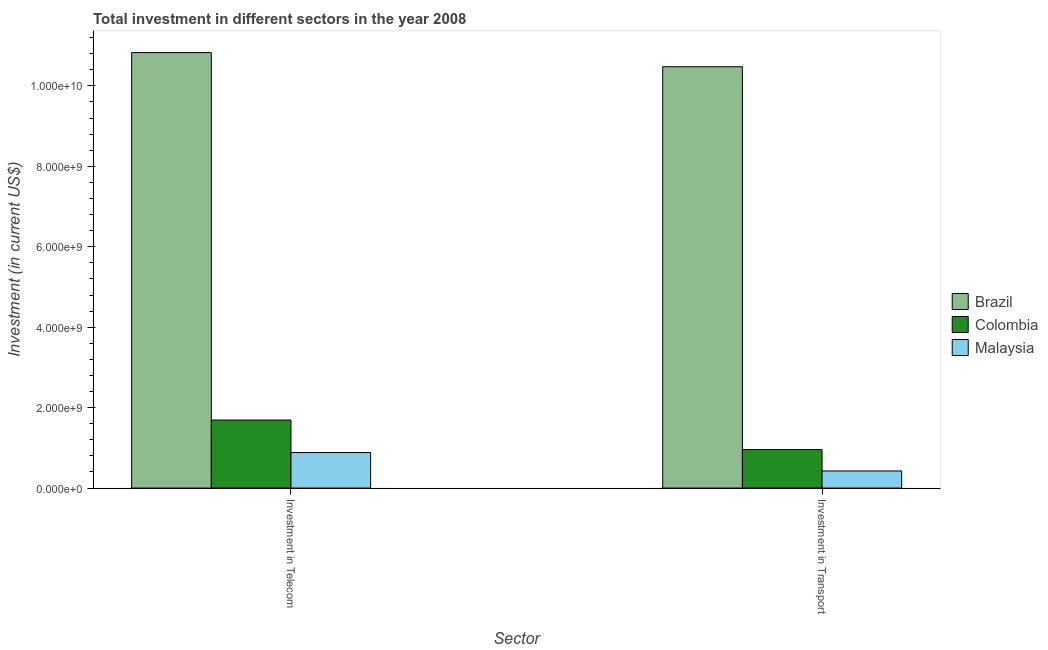How many groups of bars are there?
Offer a terse response. 2. What is the label of the 2nd group of bars from the left?
Your response must be concise. Investment in Transport. What is the investment in telecom in Malaysia?
Your answer should be very brief. 8.82e+08. Across all countries, what is the maximum investment in telecom?
Offer a terse response. 1.08e+1. Across all countries, what is the minimum investment in telecom?
Your response must be concise. 8.82e+08. In which country was the investment in transport maximum?
Your answer should be very brief. Brazil. In which country was the investment in telecom minimum?
Give a very brief answer. Malaysia. What is the total investment in telecom in the graph?
Ensure brevity in your answer.  1.34e+1. What is the difference between the investment in telecom in Colombia and that in Brazil?
Your answer should be very brief. -9.14e+09. What is the difference between the investment in telecom in Colombia and the investment in transport in Brazil?
Give a very brief answer. -8.79e+09. What is the average investment in telecom per country?
Your answer should be compact. 4.47e+09. What is the difference between the investment in telecom and investment in transport in Colombia?
Your response must be concise. 7.35e+08. In how many countries, is the investment in telecom greater than 10800000000 US$?
Provide a short and direct response. 1. What is the ratio of the investment in telecom in Colombia to that in Brazil?
Provide a succinct answer. 0.16. Is the investment in telecom in Brazil less than that in Malaysia?
Your response must be concise. No. What does the 2nd bar from the left in Investment in Telecom represents?
Ensure brevity in your answer.  Colombia. How many countries are there in the graph?
Ensure brevity in your answer.  3. Does the graph contain any zero values?
Ensure brevity in your answer.  No. Where does the legend appear in the graph?
Give a very brief answer. Center right. How many legend labels are there?
Your answer should be compact. 3. How are the legend labels stacked?
Offer a terse response. Vertical. What is the title of the graph?
Keep it short and to the point. Total investment in different sectors in the year 2008. What is the label or title of the X-axis?
Offer a very short reply. Sector. What is the label or title of the Y-axis?
Keep it short and to the point. Investment (in current US$). What is the Investment (in current US$) in Brazil in Investment in Telecom?
Your answer should be compact. 1.08e+1. What is the Investment (in current US$) of Colombia in Investment in Telecom?
Offer a terse response. 1.69e+09. What is the Investment (in current US$) in Malaysia in Investment in Telecom?
Offer a very short reply. 8.82e+08. What is the Investment (in current US$) in Brazil in Investment in Transport?
Offer a terse response. 1.05e+1. What is the Investment (in current US$) of Colombia in Investment in Transport?
Offer a terse response. 9.56e+08. What is the Investment (in current US$) of Malaysia in Investment in Transport?
Offer a very short reply. 4.25e+08. Across all Sector, what is the maximum Investment (in current US$) in Brazil?
Provide a succinct answer. 1.08e+1. Across all Sector, what is the maximum Investment (in current US$) in Colombia?
Keep it short and to the point. 1.69e+09. Across all Sector, what is the maximum Investment (in current US$) in Malaysia?
Your response must be concise. 8.82e+08. Across all Sector, what is the minimum Investment (in current US$) of Brazil?
Offer a terse response. 1.05e+1. Across all Sector, what is the minimum Investment (in current US$) of Colombia?
Ensure brevity in your answer.  9.56e+08. Across all Sector, what is the minimum Investment (in current US$) of Malaysia?
Your answer should be very brief. 4.25e+08. What is the total Investment (in current US$) in Brazil in the graph?
Provide a short and direct response. 2.13e+1. What is the total Investment (in current US$) in Colombia in the graph?
Offer a terse response. 2.65e+09. What is the total Investment (in current US$) of Malaysia in the graph?
Offer a terse response. 1.31e+09. What is the difference between the Investment (in current US$) of Brazil in Investment in Telecom and that in Investment in Transport?
Give a very brief answer. 3.52e+08. What is the difference between the Investment (in current US$) of Colombia in Investment in Telecom and that in Investment in Transport?
Give a very brief answer. 7.35e+08. What is the difference between the Investment (in current US$) in Malaysia in Investment in Telecom and that in Investment in Transport?
Provide a succinct answer. 4.57e+08. What is the difference between the Investment (in current US$) of Brazil in Investment in Telecom and the Investment (in current US$) of Colombia in Investment in Transport?
Your answer should be very brief. 9.87e+09. What is the difference between the Investment (in current US$) in Brazil in Investment in Telecom and the Investment (in current US$) in Malaysia in Investment in Transport?
Provide a short and direct response. 1.04e+1. What is the difference between the Investment (in current US$) in Colombia in Investment in Telecom and the Investment (in current US$) in Malaysia in Investment in Transport?
Your response must be concise. 1.27e+09. What is the average Investment (in current US$) in Brazil per Sector?
Your answer should be very brief. 1.07e+1. What is the average Investment (in current US$) of Colombia per Sector?
Provide a succinct answer. 1.32e+09. What is the average Investment (in current US$) of Malaysia per Sector?
Your response must be concise. 6.54e+08. What is the difference between the Investment (in current US$) in Brazil and Investment (in current US$) in Colombia in Investment in Telecom?
Offer a very short reply. 9.14e+09. What is the difference between the Investment (in current US$) in Brazil and Investment (in current US$) in Malaysia in Investment in Telecom?
Keep it short and to the point. 9.95e+09. What is the difference between the Investment (in current US$) in Colombia and Investment (in current US$) in Malaysia in Investment in Telecom?
Provide a short and direct response. 8.09e+08. What is the difference between the Investment (in current US$) of Brazil and Investment (in current US$) of Colombia in Investment in Transport?
Make the answer very short. 9.52e+09. What is the difference between the Investment (in current US$) in Brazil and Investment (in current US$) in Malaysia in Investment in Transport?
Ensure brevity in your answer.  1.01e+1. What is the difference between the Investment (in current US$) in Colombia and Investment (in current US$) in Malaysia in Investment in Transport?
Give a very brief answer. 5.31e+08. What is the ratio of the Investment (in current US$) of Brazil in Investment in Telecom to that in Investment in Transport?
Your response must be concise. 1.03. What is the ratio of the Investment (in current US$) in Colombia in Investment in Telecom to that in Investment in Transport?
Your answer should be compact. 1.77. What is the ratio of the Investment (in current US$) of Malaysia in Investment in Telecom to that in Investment in Transport?
Provide a succinct answer. 2.08. What is the difference between the highest and the second highest Investment (in current US$) in Brazil?
Provide a short and direct response. 3.52e+08. What is the difference between the highest and the second highest Investment (in current US$) of Colombia?
Give a very brief answer. 7.35e+08. What is the difference between the highest and the second highest Investment (in current US$) in Malaysia?
Your answer should be very brief. 4.57e+08. What is the difference between the highest and the lowest Investment (in current US$) in Brazil?
Offer a very short reply. 3.52e+08. What is the difference between the highest and the lowest Investment (in current US$) in Colombia?
Your answer should be compact. 7.35e+08. What is the difference between the highest and the lowest Investment (in current US$) in Malaysia?
Provide a succinct answer. 4.57e+08. 